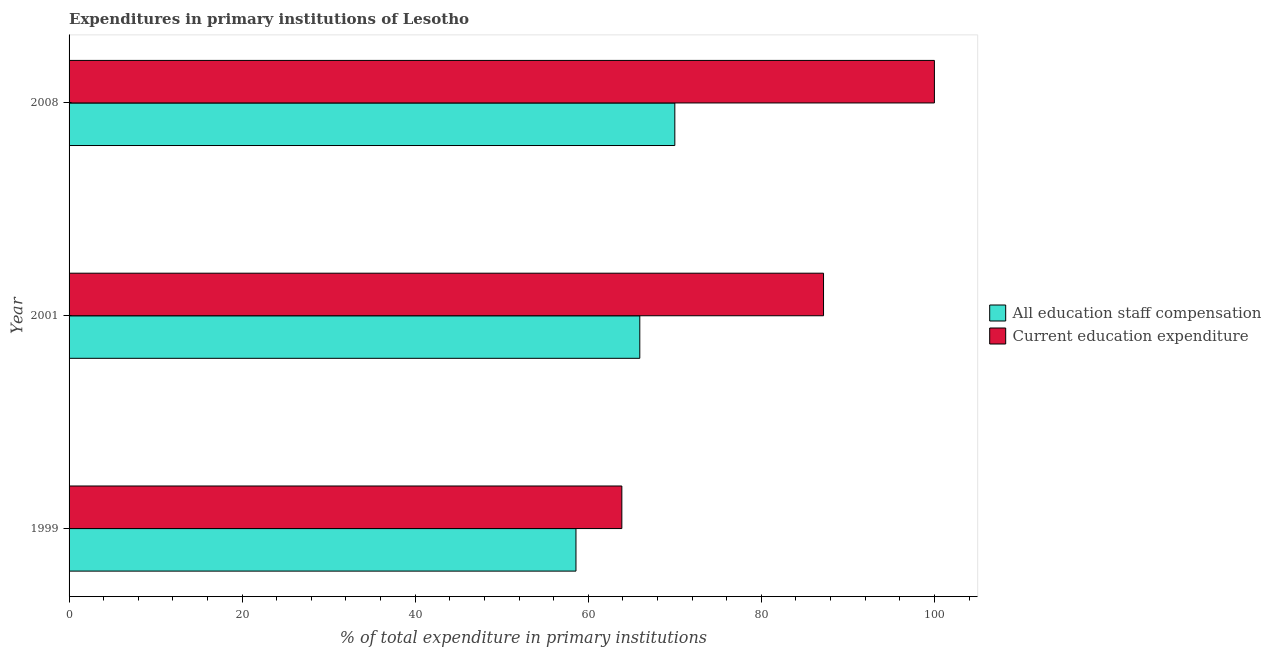What is the label of the 2nd group of bars from the top?
Your answer should be very brief. 2001. In how many cases, is the number of bars for a given year not equal to the number of legend labels?
Give a very brief answer. 0. What is the expenditure in education in 2001?
Offer a terse response. 87.19. Across all years, what is the minimum expenditure in staff compensation?
Your response must be concise. 58.58. In which year was the expenditure in staff compensation maximum?
Make the answer very short. 2008. What is the total expenditure in staff compensation in the graph?
Give a very brief answer. 194.53. What is the difference between the expenditure in staff compensation in 1999 and that in 2008?
Provide a short and direct response. -11.43. What is the difference between the expenditure in education in 2008 and the expenditure in staff compensation in 2001?
Your response must be concise. 34.05. What is the average expenditure in staff compensation per year?
Make the answer very short. 64.84. In the year 2008, what is the difference between the expenditure in staff compensation and expenditure in education?
Make the answer very short. -30. What is the ratio of the expenditure in education in 1999 to that in 2001?
Provide a short and direct response. 0.73. Is the expenditure in staff compensation in 2001 less than that in 2008?
Ensure brevity in your answer.  Yes. What is the difference between the highest and the second highest expenditure in education?
Keep it short and to the point. 12.81. What is the difference between the highest and the lowest expenditure in staff compensation?
Offer a very short reply. 11.43. In how many years, is the expenditure in education greater than the average expenditure in education taken over all years?
Your answer should be very brief. 2. What does the 2nd bar from the top in 2008 represents?
Ensure brevity in your answer.  All education staff compensation. What does the 2nd bar from the bottom in 1999 represents?
Ensure brevity in your answer.  Current education expenditure. How many years are there in the graph?
Offer a terse response. 3. What is the difference between two consecutive major ticks on the X-axis?
Offer a terse response. 20. Does the graph contain any zero values?
Your answer should be compact. No. Does the graph contain grids?
Give a very brief answer. No. What is the title of the graph?
Offer a very short reply. Expenditures in primary institutions of Lesotho. Does "Measles" appear as one of the legend labels in the graph?
Your response must be concise. No. What is the label or title of the X-axis?
Ensure brevity in your answer.  % of total expenditure in primary institutions. What is the % of total expenditure in primary institutions of All education staff compensation in 1999?
Provide a short and direct response. 58.58. What is the % of total expenditure in primary institutions in Current education expenditure in 1999?
Your answer should be very brief. 63.88. What is the % of total expenditure in primary institutions in All education staff compensation in 2001?
Give a very brief answer. 65.95. What is the % of total expenditure in primary institutions of Current education expenditure in 2001?
Provide a succinct answer. 87.19. What is the % of total expenditure in primary institutions of All education staff compensation in 2008?
Make the answer very short. 70. Across all years, what is the maximum % of total expenditure in primary institutions in All education staff compensation?
Your response must be concise. 70. Across all years, what is the minimum % of total expenditure in primary institutions of All education staff compensation?
Your response must be concise. 58.58. Across all years, what is the minimum % of total expenditure in primary institutions in Current education expenditure?
Give a very brief answer. 63.88. What is the total % of total expenditure in primary institutions in All education staff compensation in the graph?
Your answer should be very brief. 194.53. What is the total % of total expenditure in primary institutions of Current education expenditure in the graph?
Provide a short and direct response. 251.06. What is the difference between the % of total expenditure in primary institutions in All education staff compensation in 1999 and that in 2001?
Provide a short and direct response. -7.38. What is the difference between the % of total expenditure in primary institutions in Current education expenditure in 1999 and that in 2001?
Make the answer very short. -23.31. What is the difference between the % of total expenditure in primary institutions of All education staff compensation in 1999 and that in 2008?
Provide a short and direct response. -11.43. What is the difference between the % of total expenditure in primary institutions of Current education expenditure in 1999 and that in 2008?
Ensure brevity in your answer.  -36.12. What is the difference between the % of total expenditure in primary institutions of All education staff compensation in 2001 and that in 2008?
Keep it short and to the point. -4.05. What is the difference between the % of total expenditure in primary institutions of Current education expenditure in 2001 and that in 2008?
Your response must be concise. -12.81. What is the difference between the % of total expenditure in primary institutions of All education staff compensation in 1999 and the % of total expenditure in primary institutions of Current education expenditure in 2001?
Keep it short and to the point. -28.61. What is the difference between the % of total expenditure in primary institutions of All education staff compensation in 1999 and the % of total expenditure in primary institutions of Current education expenditure in 2008?
Your answer should be compact. -41.42. What is the difference between the % of total expenditure in primary institutions of All education staff compensation in 2001 and the % of total expenditure in primary institutions of Current education expenditure in 2008?
Your answer should be very brief. -34.05. What is the average % of total expenditure in primary institutions in All education staff compensation per year?
Your answer should be compact. 64.84. What is the average % of total expenditure in primary institutions in Current education expenditure per year?
Ensure brevity in your answer.  83.69. In the year 1999, what is the difference between the % of total expenditure in primary institutions in All education staff compensation and % of total expenditure in primary institutions in Current education expenditure?
Make the answer very short. -5.3. In the year 2001, what is the difference between the % of total expenditure in primary institutions in All education staff compensation and % of total expenditure in primary institutions in Current education expenditure?
Your response must be concise. -21.23. In the year 2008, what is the difference between the % of total expenditure in primary institutions in All education staff compensation and % of total expenditure in primary institutions in Current education expenditure?
Your response must be concise. -30. What is the ratio of the % of total expenditure in primary institutions in All education staff compensation in 1999 to that in 2001?
Offer a very short reply. 0.89. What is the ratio of the % of total expenditure in primary institutions of Current education expenditure in 1999 to that in 2001?
Make the answer very short. 0.73. What is the ratio of the % of total expenditure in primary institutions in All education staff compensation in 1999 to that in 2008?
Offer a terse response. 0.84. What is the ratio of the % of total expenditure in primary institutions in Current education expenditure in 1999 to that in 2008?
Ensure brevity in your answer.  0.64. What is the ratio of the % of total expenditure in primary institutions in All education staff compensation in 2001 to that in 2008?
Make the answer very short. 0.94. What is the ratio of the % of total expenditure in primary institutions of Current education expenditure in 2001 to that in 2008?
Offer a very short reply. 0.87. What is the difference between the highest and the second highest % of total expenditure in primary institutions of All education staff compensation?
Offer a terse response. 4.05. What is the difference between the highest and the second highest % of total expenditure in primary institutions of Current education expenditure?
Offer a terse response. 12.81. What is the difference between the highest and the lowest % of total expenditure in primary institutions in All education staff compensation?
Offer a terse response. 11.43. What is the difference between the highest and the lowest % of total expenditure in primary institutions in Current education expenditure?
Ensure brevity in your answer.  36.12. 